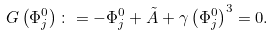Convert formula to latex. <formula><loc_0><loc_0><loc_500><loc_500>G \left ( \Phi _ { j } ^ { 0 } \right ) \colon = - \Phi _ { j } ^ { 0 } + \tilde { A } + \gamma \left ( \Phi _ { j } ^ { 0 } \right ) ^ { 3 } = 0 .</formula> 